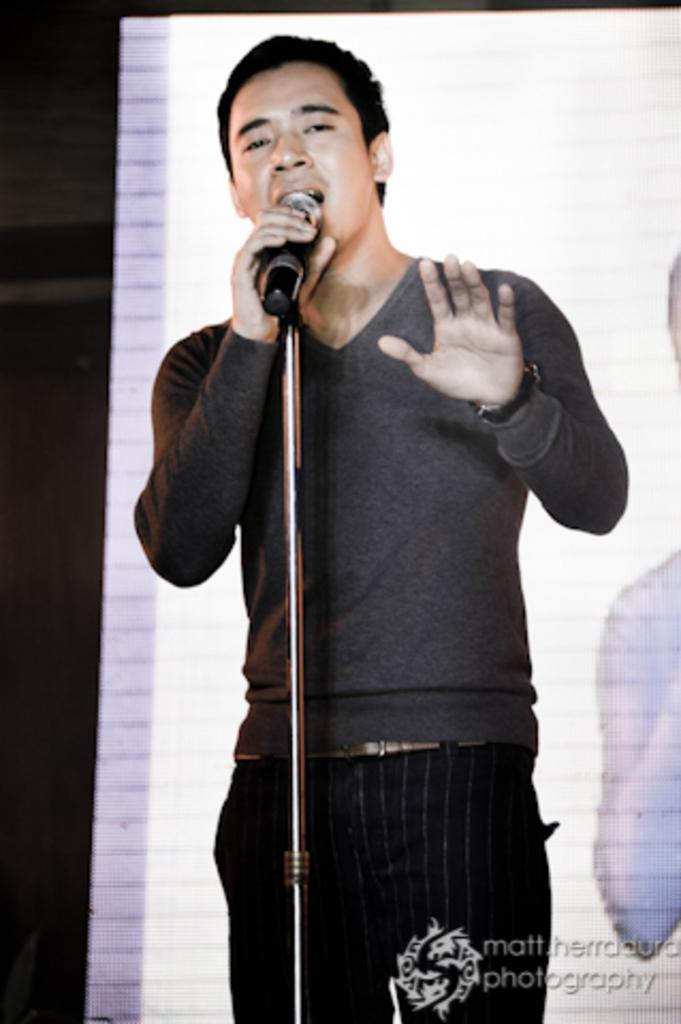What is the main subject of the image? There is a person in the image. What is the person doing in the image? The person is standing and singing a song. What object is the person holding in the image? The person is holding a microphone. What can be observed about the person's mouth in the image? The person's mouth is open. What type of nest can be seen in the image? There is no nest present in the image. What committee is responsible for organizing the event in the image? There is no event or committee mentioned in the image. 